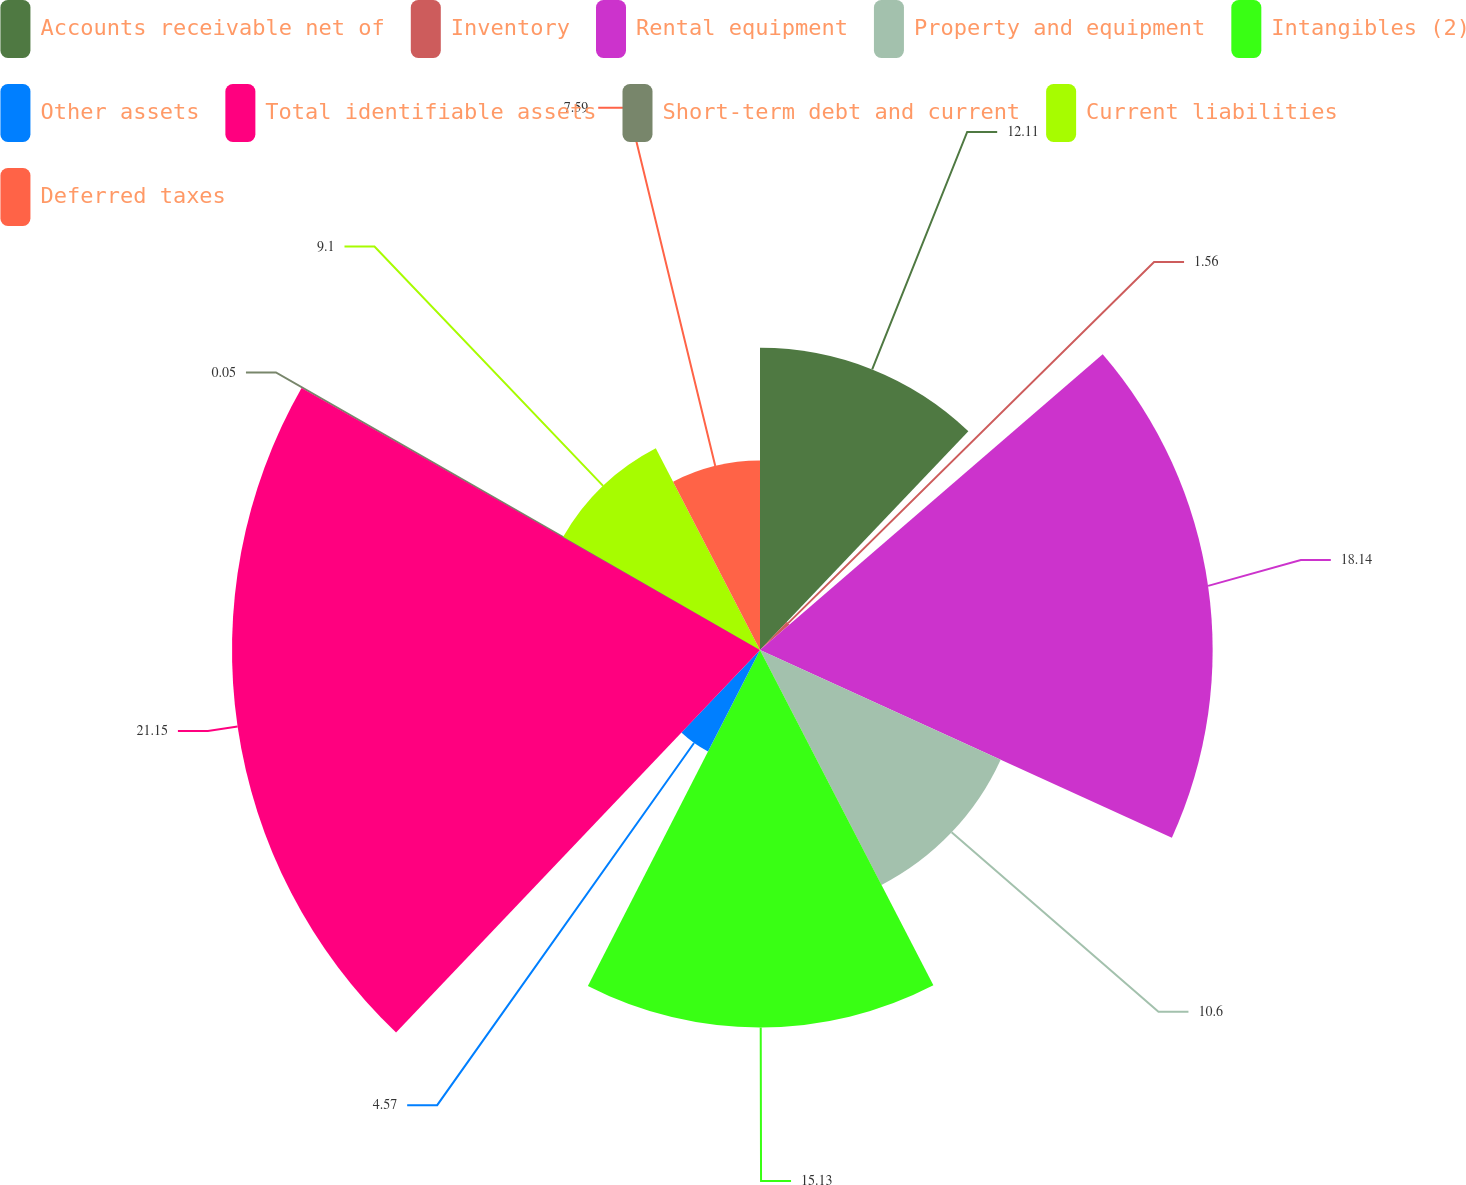Convert chart to OTSL. <chart><loc_0><loc_0><loc_500><loc_500><pie_chart><fcel>Accounts receivable net of<fcel>Inventory<fcel>Rental equipment<fcel>Property and equipment<fcel>Intangibles (2)<fcel>Other assets<fcel>Total identifiable assets<fcel>Short-term debt and current<fcel>Current liabilities<fcel>Deferred taxes<nl><fcel>12.11%<fcel>1.56%<fcel>18.14%<fcel>10.6%<fcel>15.13%<fcel>4.57%<fcel>21.16%<fcel>0.05%<fcel>9.1%<fcel>7.59%<nl></chart> 